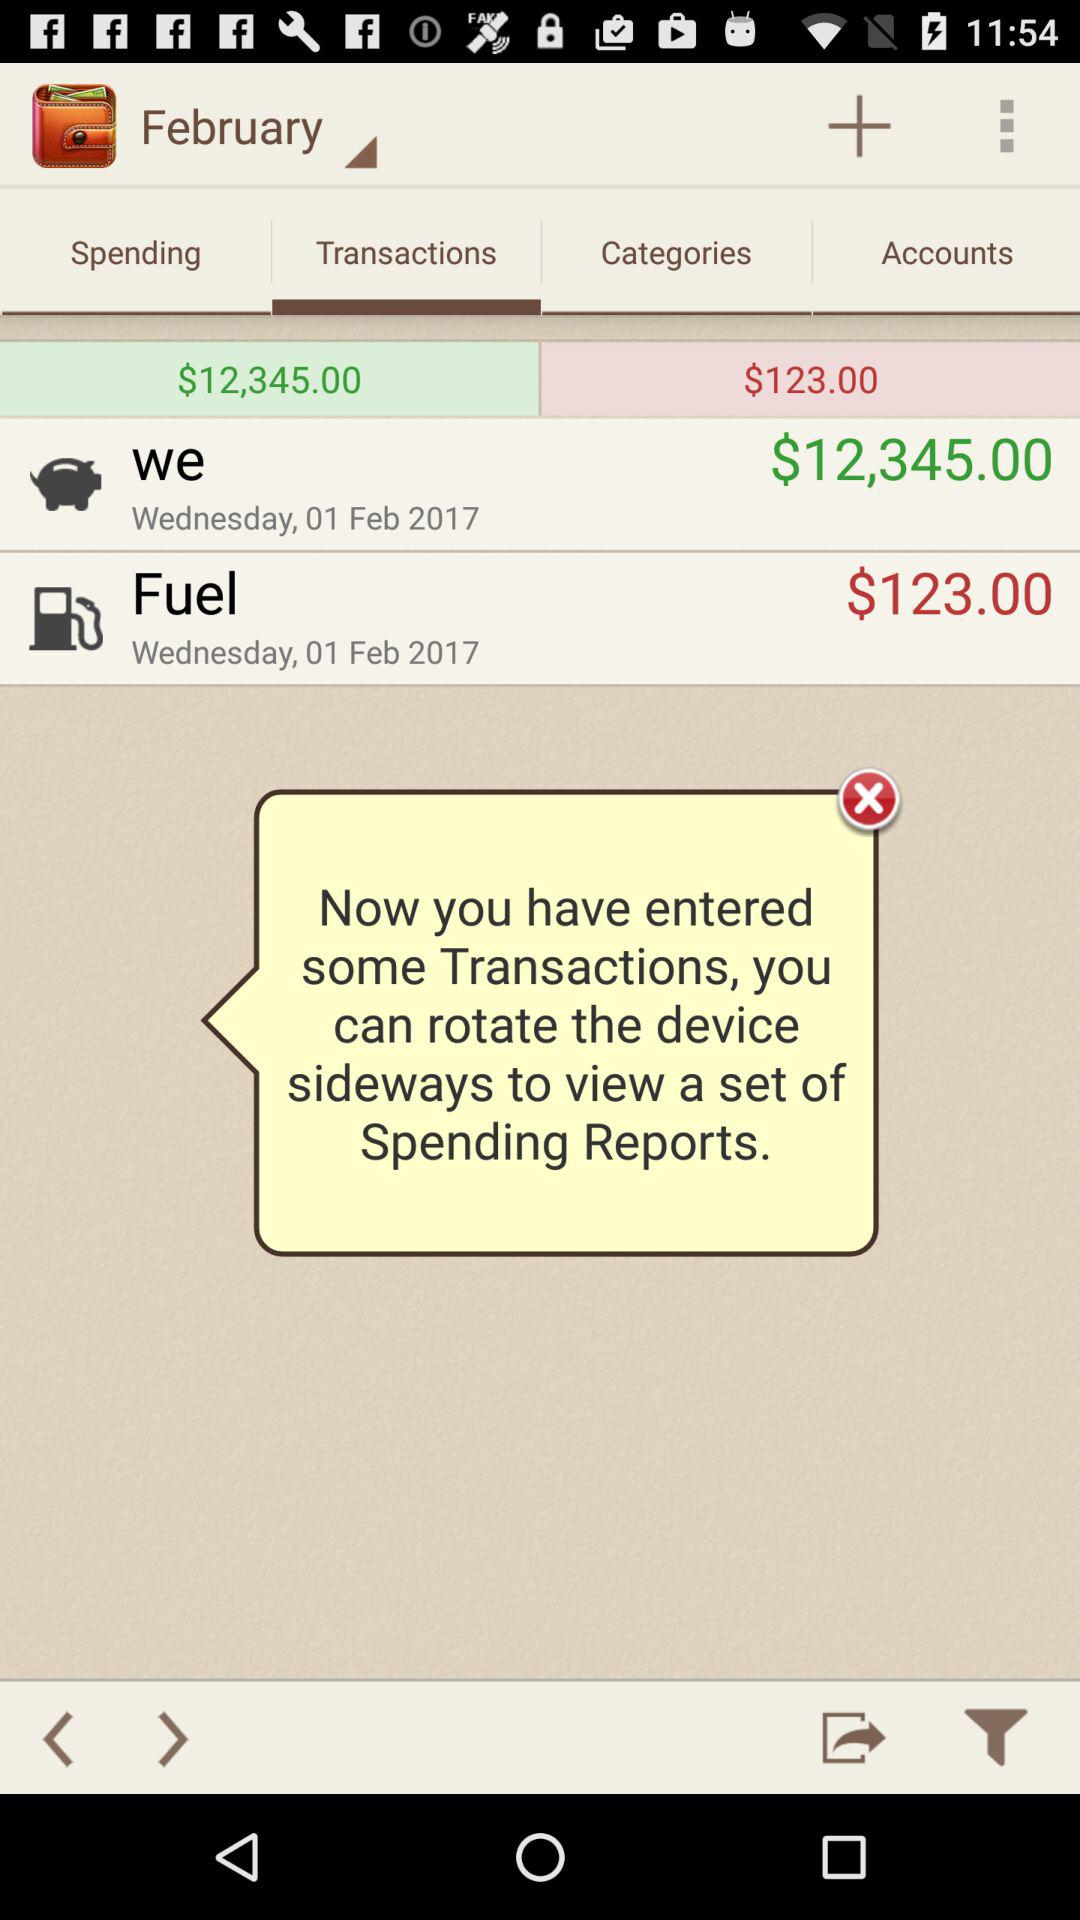How many transactions are there?
Answer the question using a single word or phrase. 2 